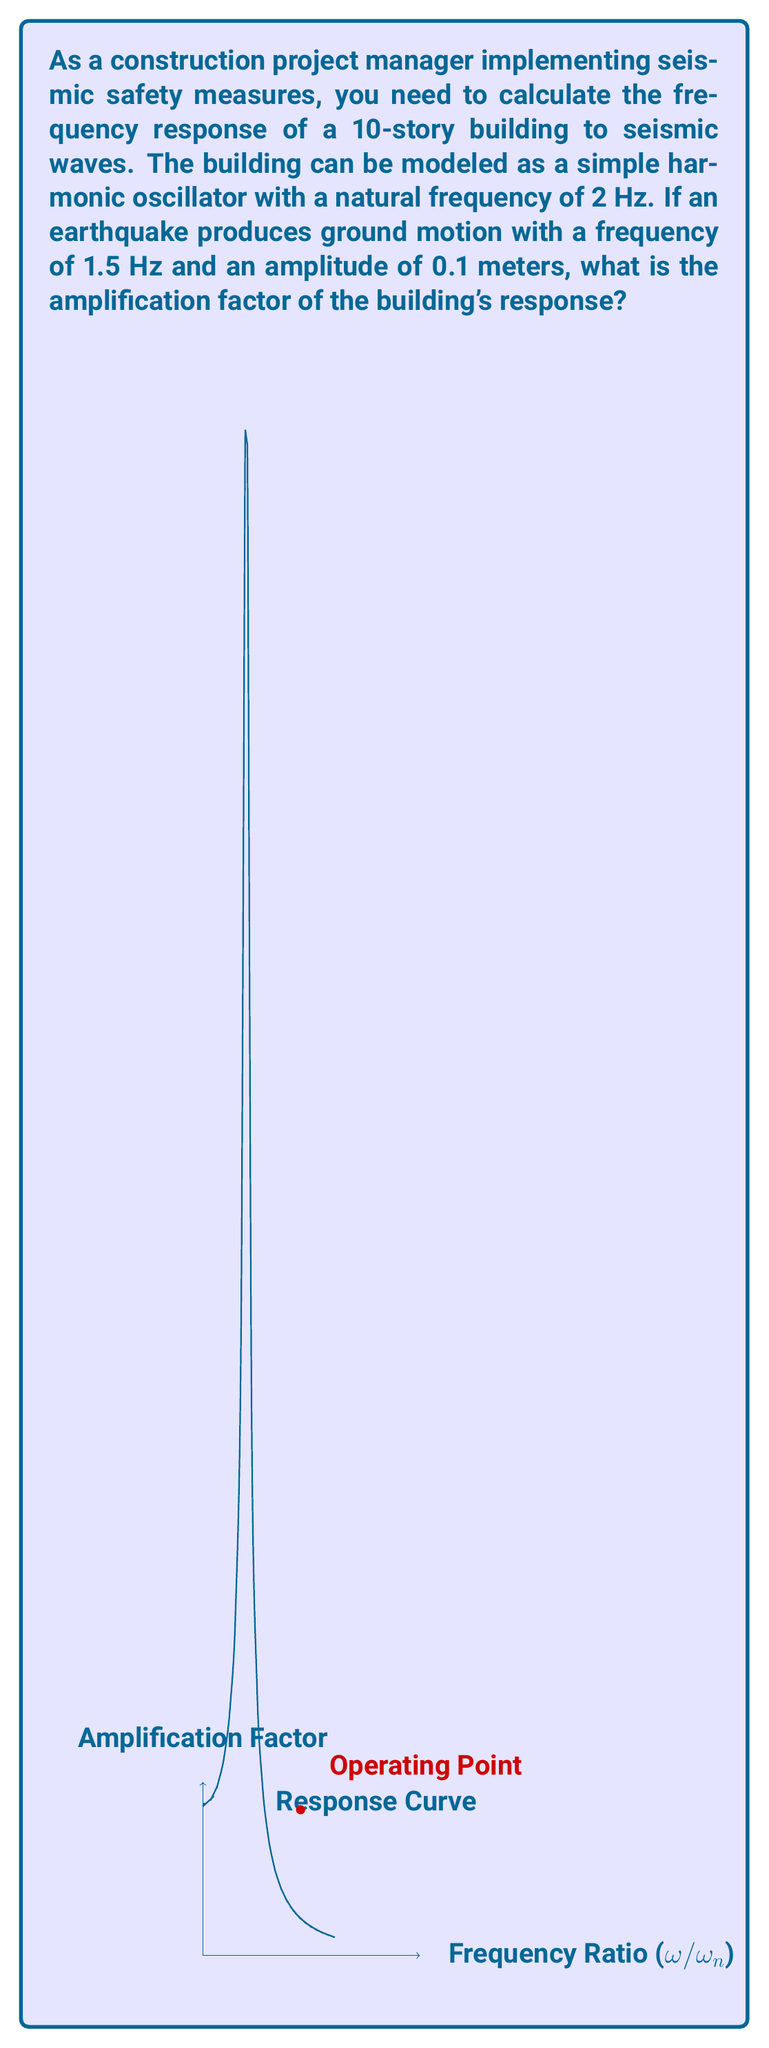Show me your answer to this math problem. To solve this problem, we'll follow these steps:

1) The amplification factor for a simple harmonic oscillator is given by the equation:

   $$A = \frac{1}{\sqrt{(1-r^2)^2 + (2\zeta r)^2}}$$

   Where:
   $A$ is the amplification factor
   $r$ is the frequency ratio $(\omega/\omega_n)$
   $\zeta$ is the damping ratio (assumed to be 0.05 for typical buildings)

2) Calculate the frequency ratio $r$:
   $$r = \frac{\omega}{\omega_n} = \frac{1.5 \text{ Hz}}{2 \text{ Hz}} = 0.75$$

3) Substitute the values into the equation:
   $$A = \frac{1}{\sqrt{(1-(0.75)^2)^2 + (2(0.05)(0.75))^2}}$$

4) Simplify:
   $$A = \frac{1}{\sqrt{(1-0.5625)^2 + (0.075)^2}}$$
   $$A = \frac{1}{\sqrt{(0.4375)^2 + 0.005625}}$$
   $$A = \frac{1}{\sqrt{0.191406 + 0.005625}}$$
   $$A = \frac{1}{\sqrt{0.197031}}$$

5) Calculate the final result:
   $$A = \frac{1}{0.4439} \approx 2.2527$$

The amplification factor is approximately 2.2527, meaning the building's response amplitude will be about 2.2527 times the ground motion amplitude.
Answer: $2.2527$ 